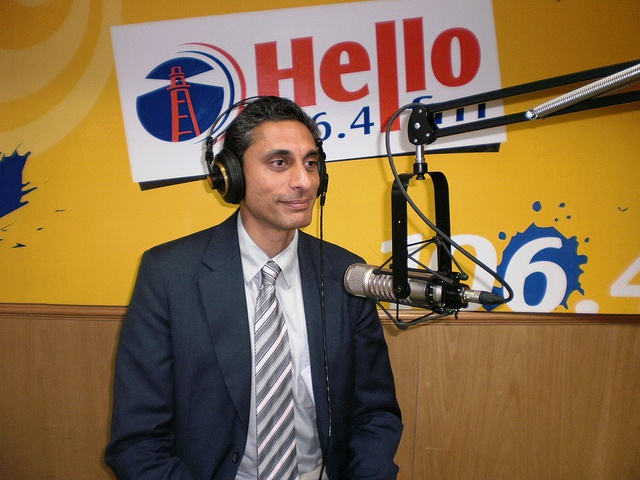Describe the objects in this image and their specific colors. I can see people in maroon, black, darkgray, and lightgray tones and tie in maroon, darkgray, gray, and lightgray tones in this image. 